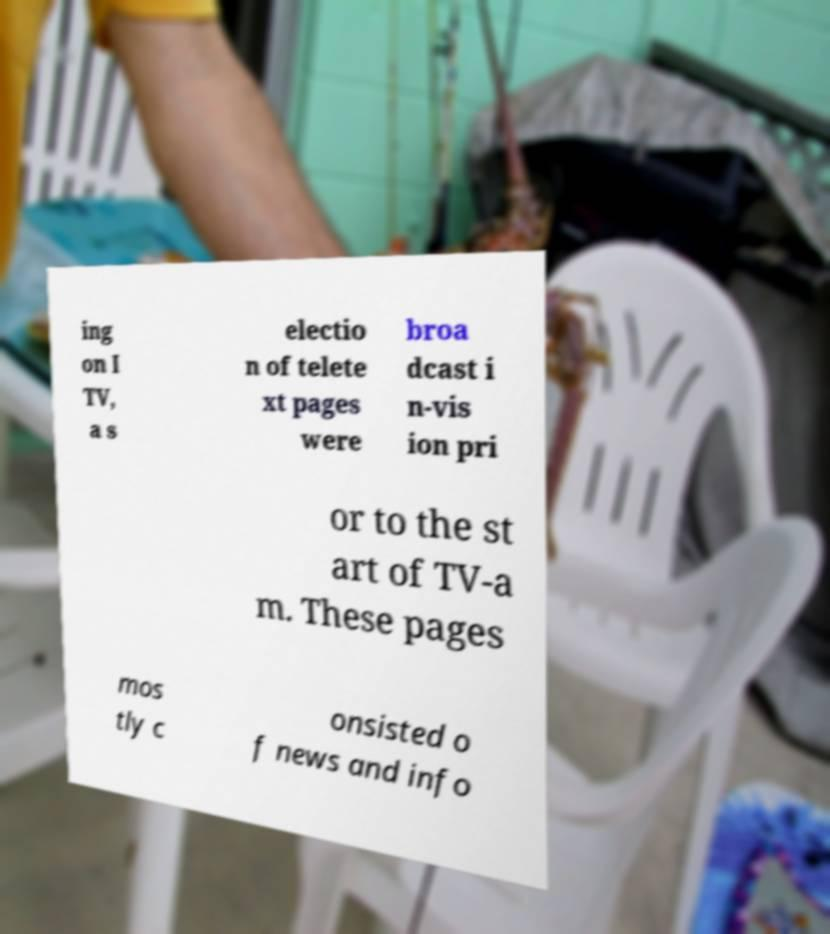Could you extract and type out the text from this image? ing on I TV, a s electio n of telete xt pages were broa dcast i n-vis ion pri or to the st art of TV-a m. These pages mos tly c onsisted o f news and info 